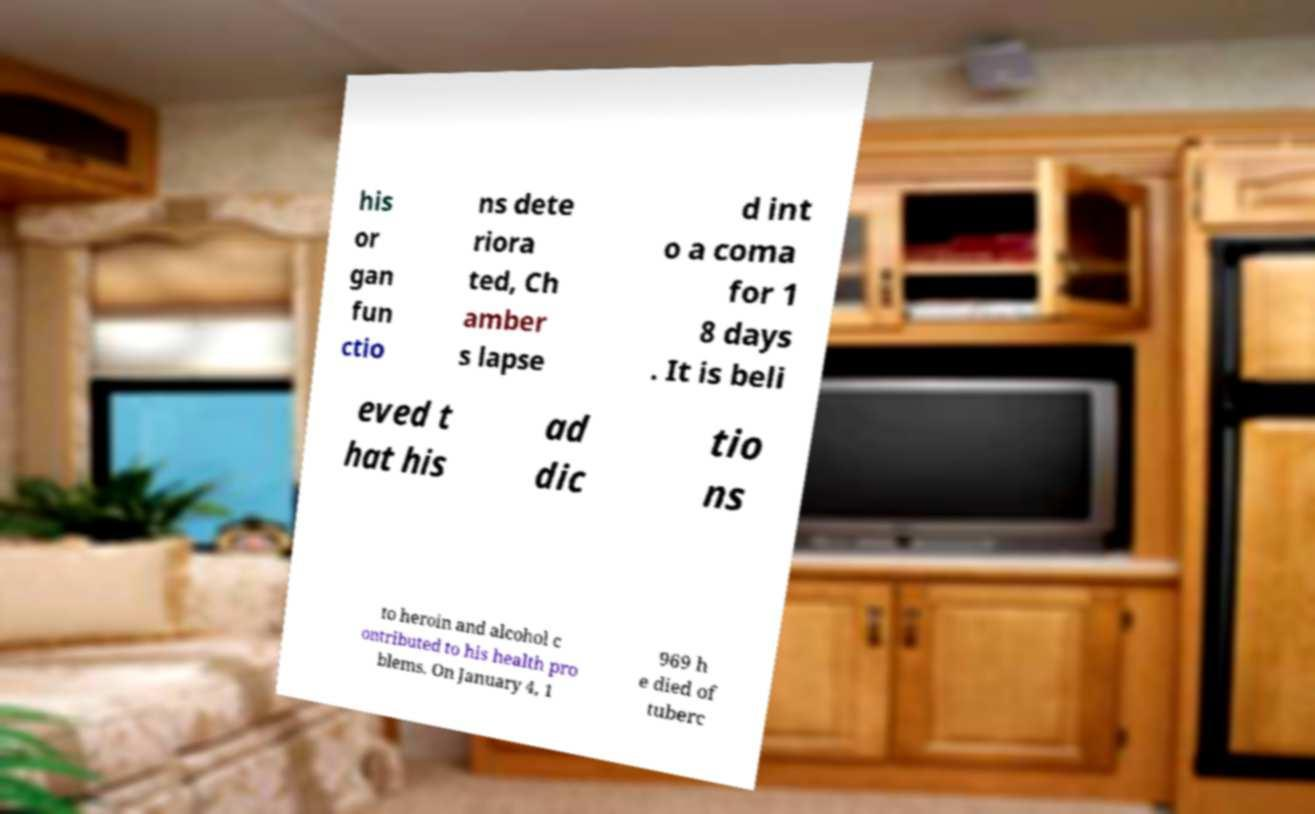There's text embedded in this image that I need extracted. Can you transcribe it verbatim? his or gan fun ctio ns dete riora ted, Ch amber s lapse d int o a coma for 1 8 days . It is beli eved t hat his ad dic tio ns to heroin and alcohol c ontributed to his health pro blems. On January 4, 1 969 h e died of tuberc 